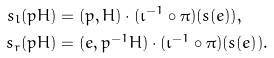<formula> <loc_0><loc_0><loc_500><loc_500>s _ { l } ( p H ) & = ( p , H ) \cdot ( \iota ^ { - 1 } \circ \pi ) ( s ( e ) ) , \\ s _ { r } ( p H ) & = ( e , p ^ { - 1 } H ) \cdot ( \iota ^ { - 1 } \circ \pi ) ( s ( e ) ) .</formula> 